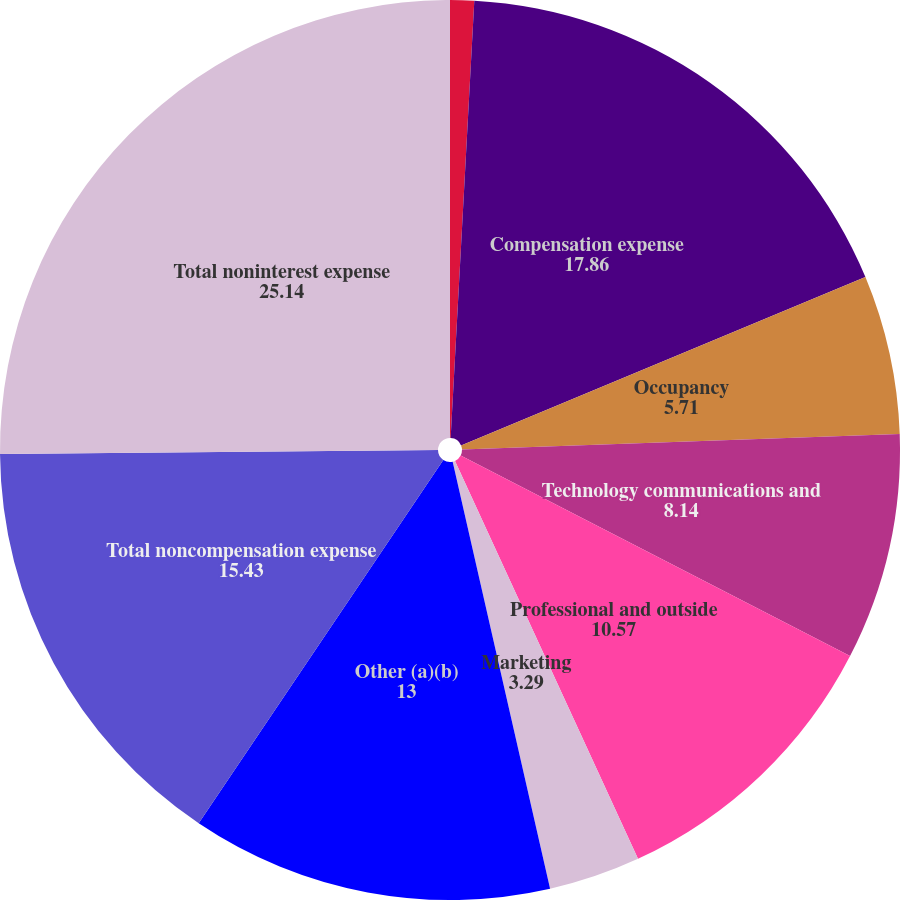Convert chart to OTSL. <chart><loc_0><loc_0><loc_500><loc_500><pie_chart><fcel>(in millions)<fcel>Compensation expense<fcel>Occupancy<fcel>Technology communications and<fcel>Professional and outside<fcel>Marketing<fcel>Other (a)(b)<fcel>Total noncompensation expense<fcel>Total noninterest expense<nl><fcel>0.86%<fcel>17.86%<fcel>5.71%<fcel>8.14%<fcel>10.57%<fcel>3.29%<fcel>13.0%<fcel>15.43%<fcel>25.14%<nl></chart> 